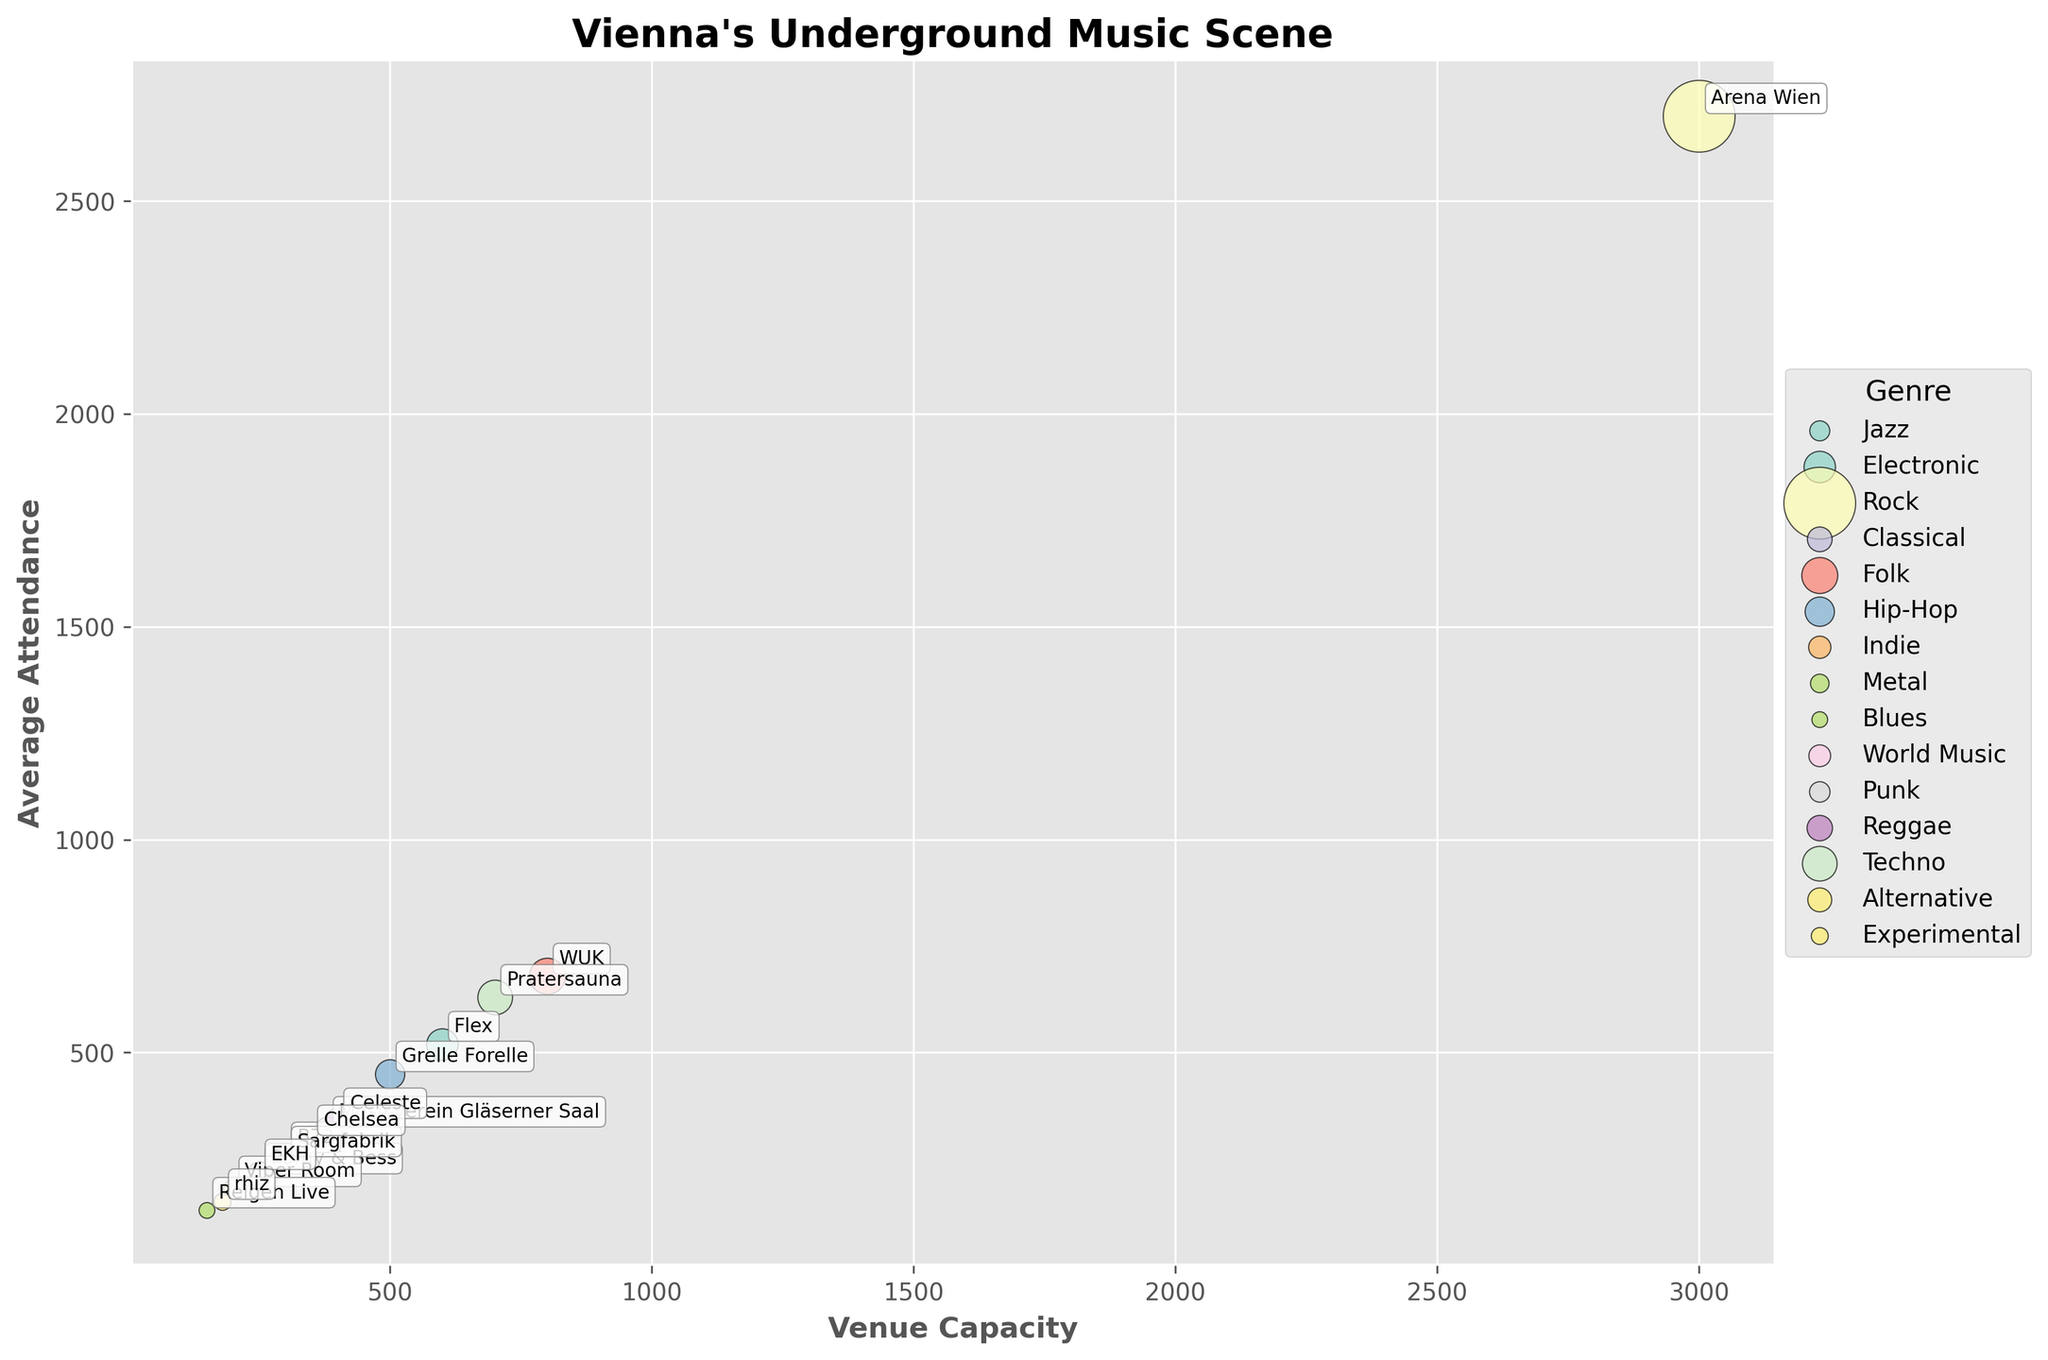How many music venues are represented in this plot? Each bubble represents a music venue on the plot. Counting all the individual bubbles shows there are 15 music venues.
Answer: 15 Which genre has the highest average attendance at a single venue? From the plot, the venue "Arena Wien" for the genre "Rock" has the highest average attendance bubble near the top right of the plot.
Answer: Rock What's the relationship between venue capacity and average attendance for "Jazz"? Check the position of the bubble for "Porgy & Bess" on the plot. Its capacity aligns with 250 and average attendance around 210, indicating that Jazz at "Porgy & Bess" has a high attendance rate relative to capacity.
Answer: Positive Which genre has venues with the smallest and highest capacities, respectively? The smallest capacity venue "Reigen Live" (Blues) and the highest capacity venue "Arena Wien" (Rock) can be identified visually at the left and right ends of the horizontal axis, respectively.
Answer: Blues, Rock How does the average attendance for "EKH" (Punk) compare to "B72" (Indie)? Locate the bubbles for "EKH" and "B72" on the plot. The average attendance for "EKH" is 220, which is slightly less than "B72" with an average attendance of 260.
Answer: Less What can be inferred about venues with capacities less than 200? The plot shows "Viper Room" (Metal) and "Rhiz" (Experimental) within this range, with average attendances of 180 and 150, respectively, suggesting smaller but consistent crowds.
Answer: Smaller and consistent attendance What's the average venue capacity for the displayed venues? Add the capacities of all venues and divide by the number of venues: (250 + 600 + 3000 + 380 + 800 + 500 + 300 + 200 + 150 + 300 + 250 + 400 + 700 + 350 + 180) / 15 = 842.67
Answer: 842.67 Compare the average attendance between "Flex" (Electronic) and "Pratersauna" (Techno) Check the bubbles for "Flex" and "Pratersauna." "Flex" has an average attendance of 520 while "Pratersauna" has 630, making Pratersauna's attendance higher.
Answer: Pratersauna higher 